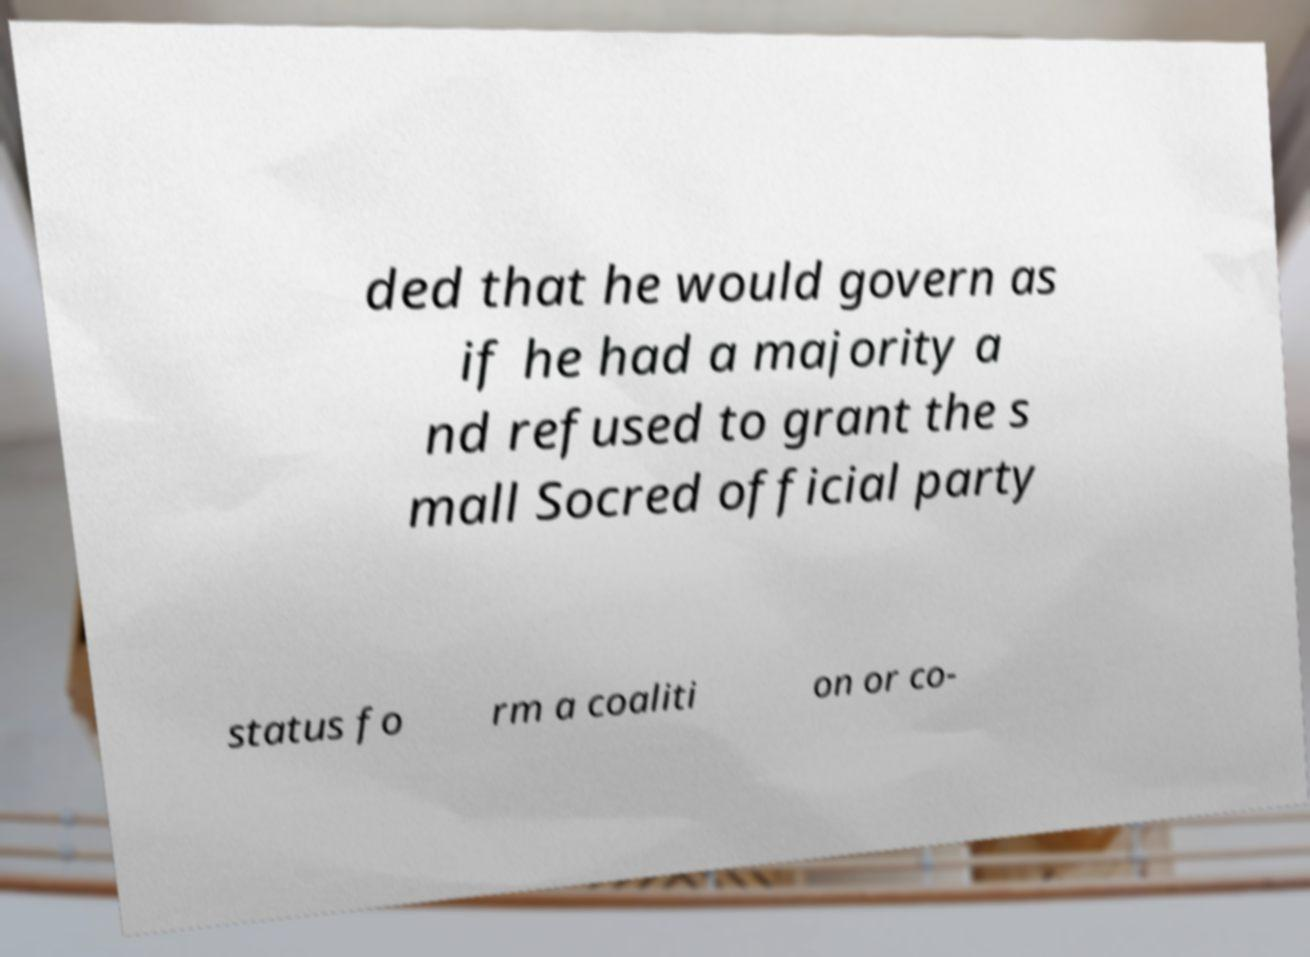For documentation purposes, I need the text within this image transcribed. Could you provide that? ded that he would govern as if he had a majority a nd refused to grant the s mall Socred official party status fo rm a coaliti on or co- 